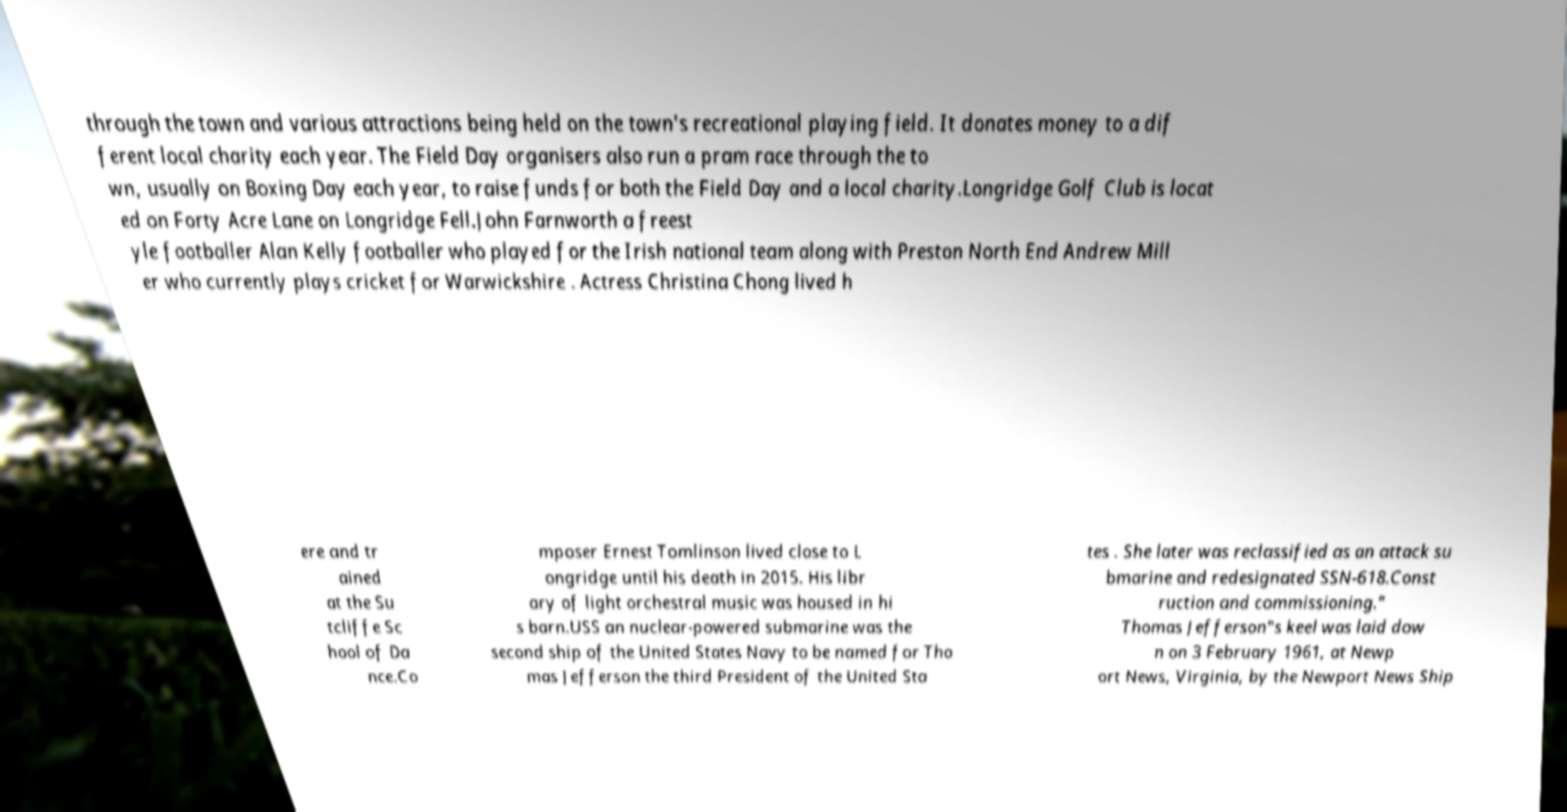Can you read and provide the text displayed in the image?This photo seems to have some interesting text. Can you extract and type it out for me? through the town and various attractions being held on the town's recreational playing field. It donates money to a dif ferent local charity each year. The Field Day organisers also run a pram race through the to wn, usually on Boxing Day each year, to raise funds for both the Field Day and a local charity.Longridge Golf Club is locat ed on Forty Acre Lane on Longridge Fell.John Farnworth a freest yle footballer Alan Kelly footballer who played for the Irish national team along with Preston North End Andrew Mill er who currently plays cricket for Warwickshire . Actress Christina Chong lived h ere and tr ained at the Su tcliffe Sc hool of Da nce.Co mposer Ernest Tomlinson lived close to L ongridge until his death in 2015. His libr ary of light orchestral music was housed in hi s barn.USS an nuclear-powered submarine was the second ship of the United States Navy to be named for Tho mas Jefferson the third President of the United Sta tes . She later was reclassified as an attack su bmarine and redesignated SSN-618.Const ruction and commissioning." Thomas Jefferson"s keel was laid dow n on 3 February 1961, at Newp ort News, Virginia, by the Newport News Ship 